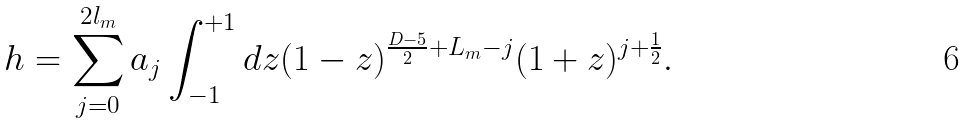Convert formula to latex. <formula><loc_0><loc_0><loc_500><loc_500>h = \sum _ { j = 0 } ^ { 2 l _ { m } } a _ { j } \int ^ { + 1 } _ { - 1 } d z ( 1 - z ) ^ { \frac { D - 5 } { 2 } + L _ { m } - j } ( 1 + z ) ^ { j + \frac { 1 } { 2 } } .</formula> 